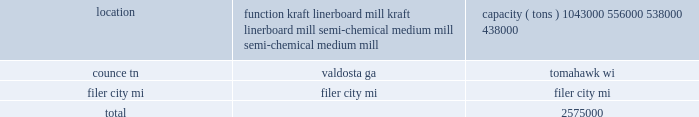Item 1b .
Unresolved staff comments item 2 .
Properties the table below provides a summary of our containerboard mills , the principal products produced and each mill 2019s year-end 2011 annual practical maximum capacity based upon all of our paper machines 2019 production capabilities , as reported to the af&pa : location function capacity ( tons ) counce , tn .
Kraft linerboard mill 1043000 valdosta , ga .
Kraft linerboard mill 556000 tomahawk , wi .
Semi-chemical medium mill 538000 filer city , mi .
Semi-chemical medium mill 438000 .
We currently own our four containerboard mills and 44 of our corrugated manufacturing operations ( 37 corrugated plants and seven sheet plants ) .
We also own one warehouse and miscellaneous other property , which includes sales offices and woodlands management offices .
These sales offices and woodlands management offices generally have one to four employees and serve as administrative offices .
Pca leases the space for four corrugated plants , 23 sheet plants , six regional design centers , and numerous other distribution centers , warehouses and facilities .
The equipment in these leased facilities is , in virtually all cases , owned by pca , except for forklifts and other rolling stock which are generally leased .
We lease the cutting rights to approximately 88000 acres of timberland located near our valdosta mill ( 77000 acres ) and our counce mill ( 11000 acres ) .
On average , these cutting rights agreements have terms with approximately 12 years remaining .
Our corporate headquarters is located in lake forest , illinois .
The headquarters facility is leased for the next ten years with provisions for two additional five year lease extensions .
Item 3 .
Legal proceedings during september and october 2010 , pca and eight other u.s .
And canadian containerboard producers were named as defendants in five purported class action lawsuits filed in the united states district court for the northern district of illinois , alleging violations of the sherman act .
The lawsuits have been consolidated in a single complaint under the caption kleen products llc v packaging corp .
Of america et al .
The consolidated complaint alleges that the defendants conspired to limit the supply of containerboard , and that the purpose and effect of the alleged conspiracy was to artificially increase prices of containerboard products during the period from august 2005 to the time of filing of the complaints .
The complaint was filed as a purported class action suit on behalf of all purchasers of containerboard products during such period .
The complaint seeks treble damages and costs , including attorney 2019s fees .
The defendants 2019 motions to dismiss the complaint were denied by the court in april 2011 .
Pca believes the allegations are without merit and will defend this lawsuit vigorously .
However , as the lawsuit is in the early stages of discovery , pca is unable to predict the ultimate outcome or estimate a range of reasonably possible losses .
Pca is a party to various other legal actions arising in the ordinary course of our business .
These legal actions cover a broad variety of claims spanning our entire business .
As of the date of this filing , we believe it is not reasonably possible that the resolution of these legal actions will , individually or in the aggregate , have a material adverse effect on our financial condition , results of operations or cash flows. .
What is the total number of containerboard mills and corrugated manufacturing operations? 
Computations: (4 + 44)
Answer: 48.0. Item 1b .
Unresolved staff comments item 2 .
Properties the table below provides a summary of our containerboard mills , the principal products produced and each mill 2019s year-end 2011 annual practical maximum capacity based upon all of our paper machines 2019 production capabilities , as reported to the af&pa : location function capacity ( tons ) counce , tn .
Kraft linerboard mill 1043000 valdosta , ga .
Kraft linerboard mill 556000 tomahawk , wi .
Semi-chemical medium mill 538000 filer city , mi .
Semi-chemical medium mill 438000 .
We currently own our four containerboard mills and 44 of our corrugated manufacturing operations ( 37 corrugated plants and seven sheet plants ) .
We also own one warehouse and miscellaneous other property , which includes sales offices and woodlands management offices .
These sales offices and woodlands management offices generally have one to four employees and serve as administrative offices .
Pca leases the space for four corrugated plants , 23 sheet plants , six regional design centers , and numerous other distribution centers , warehouses and facilities .
The equipment in these leased facilities is , in virtually all cases , owned by pca , except for forklifts and other rolling stock which are generally leased .
We lease the cutting rights to approximately 88000 acres of timberland located near our valdosta mill ( 77000 acres ) and our counce mill ( 11000 acres ) .
On average , these cutting rights agreements have terms with approximately 12 years remaining .
Our corporate headquarters is located in lake forest , illinois .
The headquarters facility is leased for the next ten years with provisions for two additional five year lease extensions .
Item 3 .
Legal proceedings during september and october 2010 , pca and eight other u.s .
And canadian containerboard producers were named as defendants in five purported class action lawsuits filed in the united states district court for the northern district of illinois , alleging violations of the sherman act .
The lawsuits have been consolidated in a single complaint under the caption kleen products llc v packaging corp .
Of america et al .
The consolidated complaint alleges that the defendants conspired to limit the supply of containerboard , and that the purpose and effect of the alleged conspiracy was to artificially increase prices of containerboard products during the period from august 2005 to the time of filing of the complaints .
The complaint was filed as a purported class action suit on behalf of all purchasers of containerboard products during such period .
The complaint seeks treble damages and costs , including attorney 2019s fees .
The defendants 2019 motions to dismiss the complaint were denied by the court in april 2011 .
Pca believes the allegations are without merit and will defend this lawsuit vigorously .
However , as the lawsuit is in the early stages of discovery , pca is unable to predict the ultimate outcome or estimate a range of reasonably possible losses .
Pca is a party to various other legal actions arising in the ordinary course of our business .
These legal actions cover a broad variety of claims spanning our entire business .
As of the date of this filing , we believe it is not reasonably possible that the resolution of these legal actions will , individually or in the aggregate , have a material adverse effect on our financial condition , results of operations or cash flows. .
For the leased cutting rights to approximately 88000 acres of timberland , is the valdosta mill acreage greater than the counce mill acres? 
Computations: (77000 > 11000)
Answer: yes. 